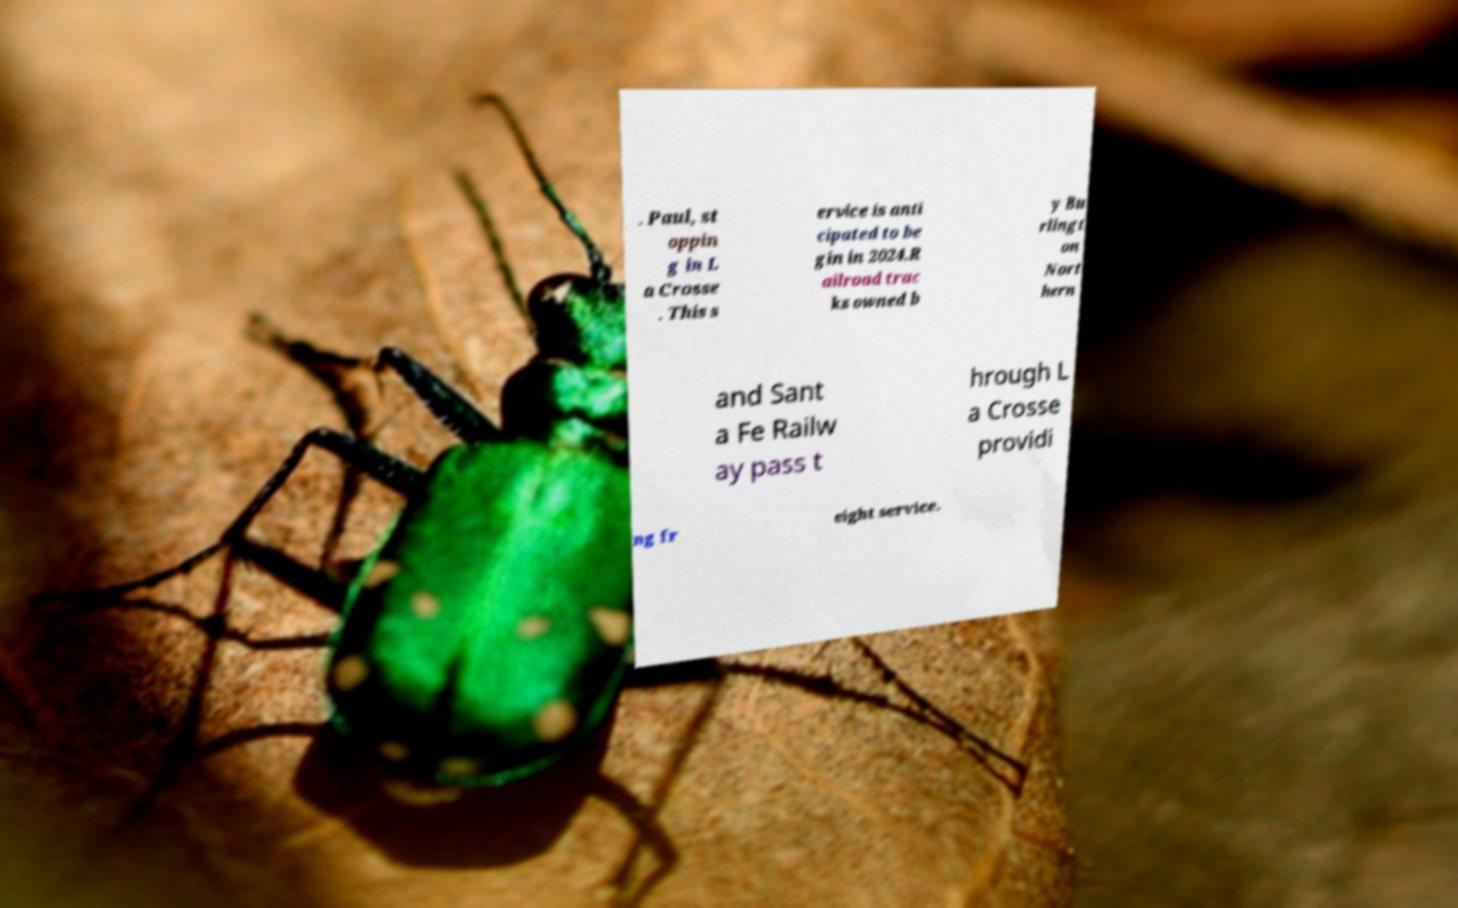Please read and relay the text visible in this image. What does it say? . Paul, st oppin g in L a Crosse . This s ervice is anti cipated to be gin in 2024.R ailroad trac ks owned b y Bu rlingt on Nort hern and Sant a Fe Railw ay pass t hrough L a Crosse providi ng fr eight service. 